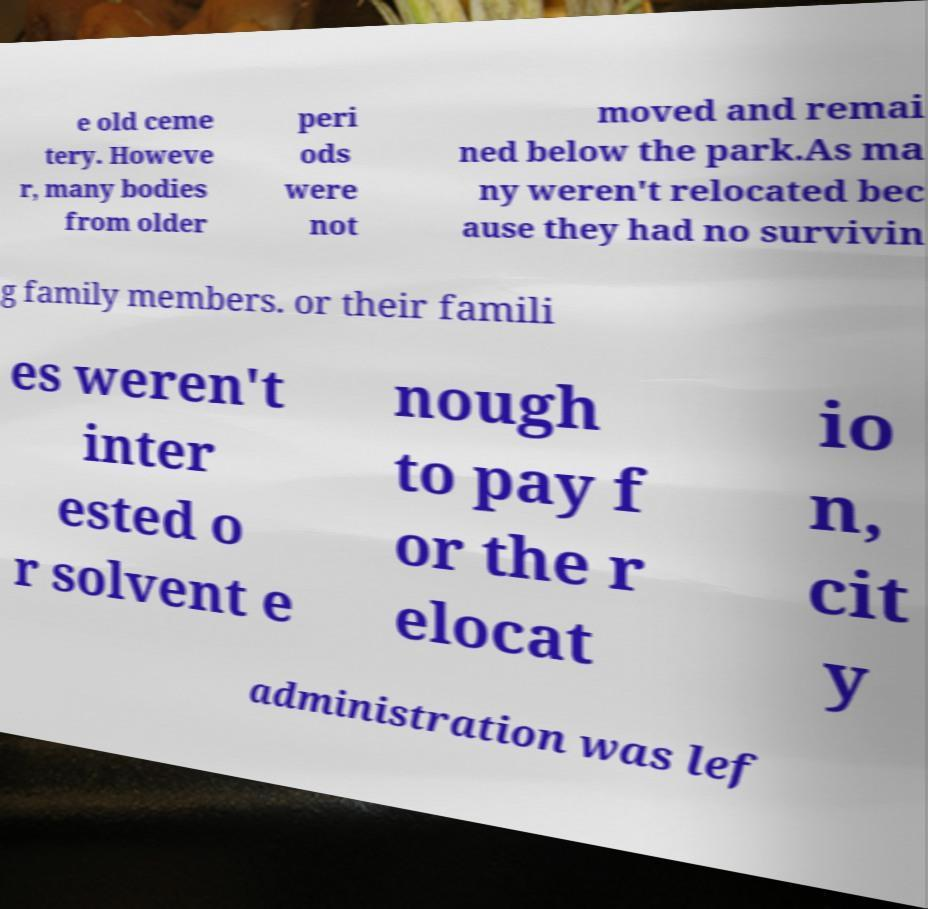I need the written content from this picture converted into text. Can you do that? e old ceme tery. Howeve r, many bodies from older peri ods were not moved and remai ned below the park.As ma ny weren't relocated bec ause they had no survivin g family members. or their famili es weren't inter ested o r solvent e nough to pay f or the r elocat io n, cit y administration was lef 